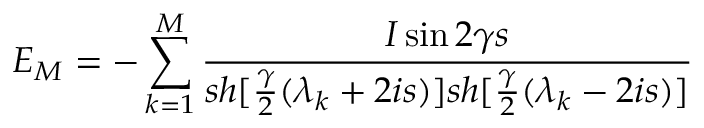<formula> <loc_0><loc_0><loc_500><loc_500>E _ { M } = - \sum _ { k = 1 } ^ { M } \frac { I \sin 2 \gamma s } { s h [ \frac { \gamma } { 2 } ( \lambda _ { k } + 2 i s ) ] s h [ \frac { \gamma } { 2 } ( \lambda _ { k } - 2 i s ) ] }</formula> 